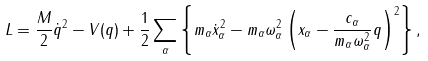<formula> <loc_0><loc_0><loc_500><loc_500>L = \frac { M } { 2 } \dot { q } ^ { 2 } - V ( q ) + \frac { 1 } { 2 } \sum _ { \alpha } \left \{ m _ { \alpha } \dot { x } _ { \alpha } ^ { 2 } - m _ { \alpha } \omega _ { \alpha } ^ { 2 } \left ( x _ { \alpha } - \frac { c _ { \alpha } } { m _ { \alpha } \omega _ { \alpha } ^ { 2 } } q \right ) ^ { 2 } \right \} ,</formula> 